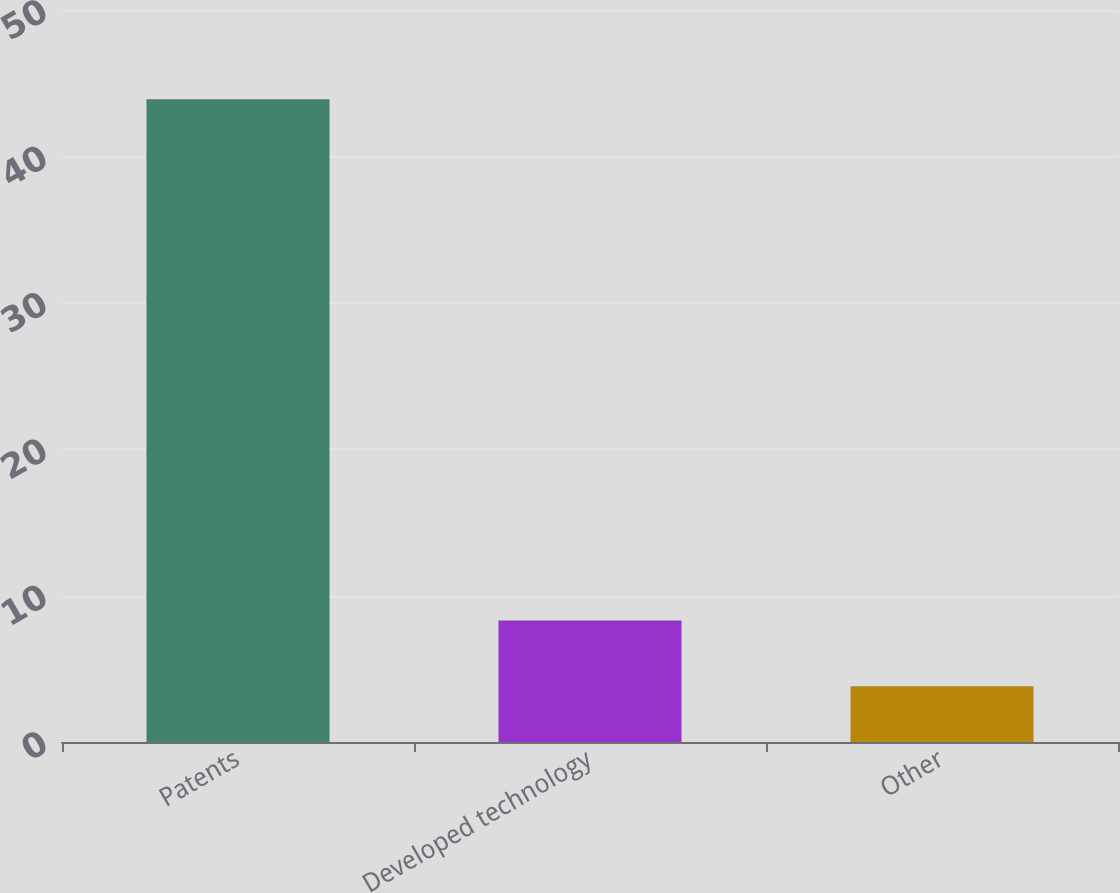<chart> <loc_0><loc_0><loc_500><loc_500><bar_chart><fcel>Patents<fcel>Developed technology<fcel>Other<nl><fcel>43.9<fcel>8.3<fcel>3.8<nl></chart> 